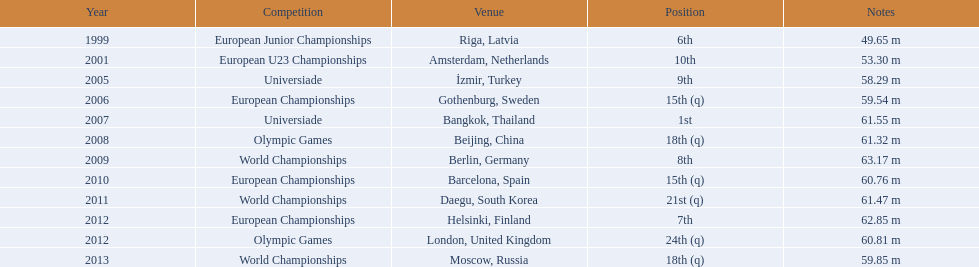During which years did gerhard mayer take part? 1999, 2001, 2005, 2006, 2007, 2008, 2009, 2010, 2011, 2012, 2012, 2013. Which of these years came before 2007? 1999, 2001, 2005, 2006. What was the highest ranking achieved in those years? 6th. Can you give me this table as a dict? {'header': ['Year', 'Competition', 'Venue', 'Position', 'Notes'], 'rows': [['1999', 'European Junior Championships', 'Riga, Latvia', '6th', '49.65 m'], ['2001', 'European U23 Championships', 'Amsterdam, Netherlands', '10th', '53.30 m'], ['2005', 'Universiade', 'İzmir, Turkey', '9th', '58.29 m'], ['2006', 'European Championships', 'Gothenburg, Sweden', '15th (q)', '59.54 m'], ['2007', 'Universiade', 'Bangkok, Thailand', '1st', '61.55 m'], ['2008', 'Olympic Games', 'Beijing, China', '18th (q)', '61.32 m'], ['2009', 'World Championships', 'Berlin, Germany', '8th', '63.17 m'], ['2010', 'European Championships', 'Barcelona, Spain', '15th (q)', '60.76 m'], ['2011', 'World Championships', 'Daegu, South Korea', '21st (q)', '61.47 m'], ['2012', 'European Championships', 'Helsinki, Finland', '7th', '62.85 m'], ['2012', 'Olympic Games', 'London, United Kingdom', '24th (q)', '60.81 m'], ['2013', 'World Championships', 'Moscow, Russia', '18th (q)', '59.85 m']]} 